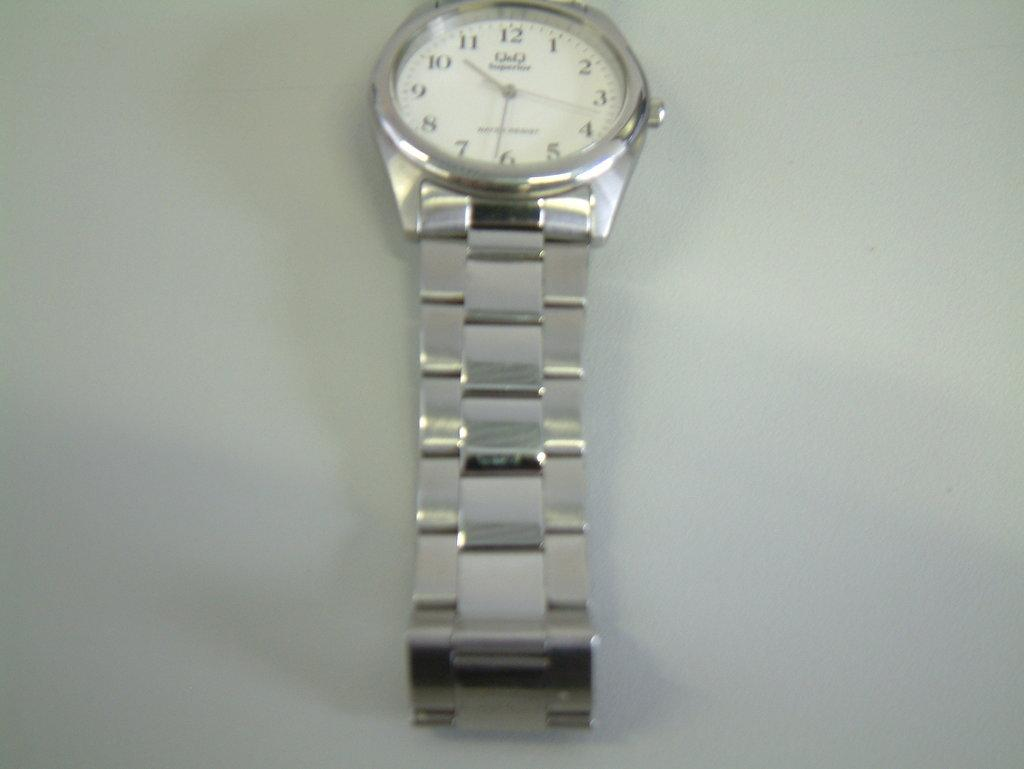<image>
Present a compact description of the photo's key features. A silver watch stretched out on a table with the number 10 showing. 